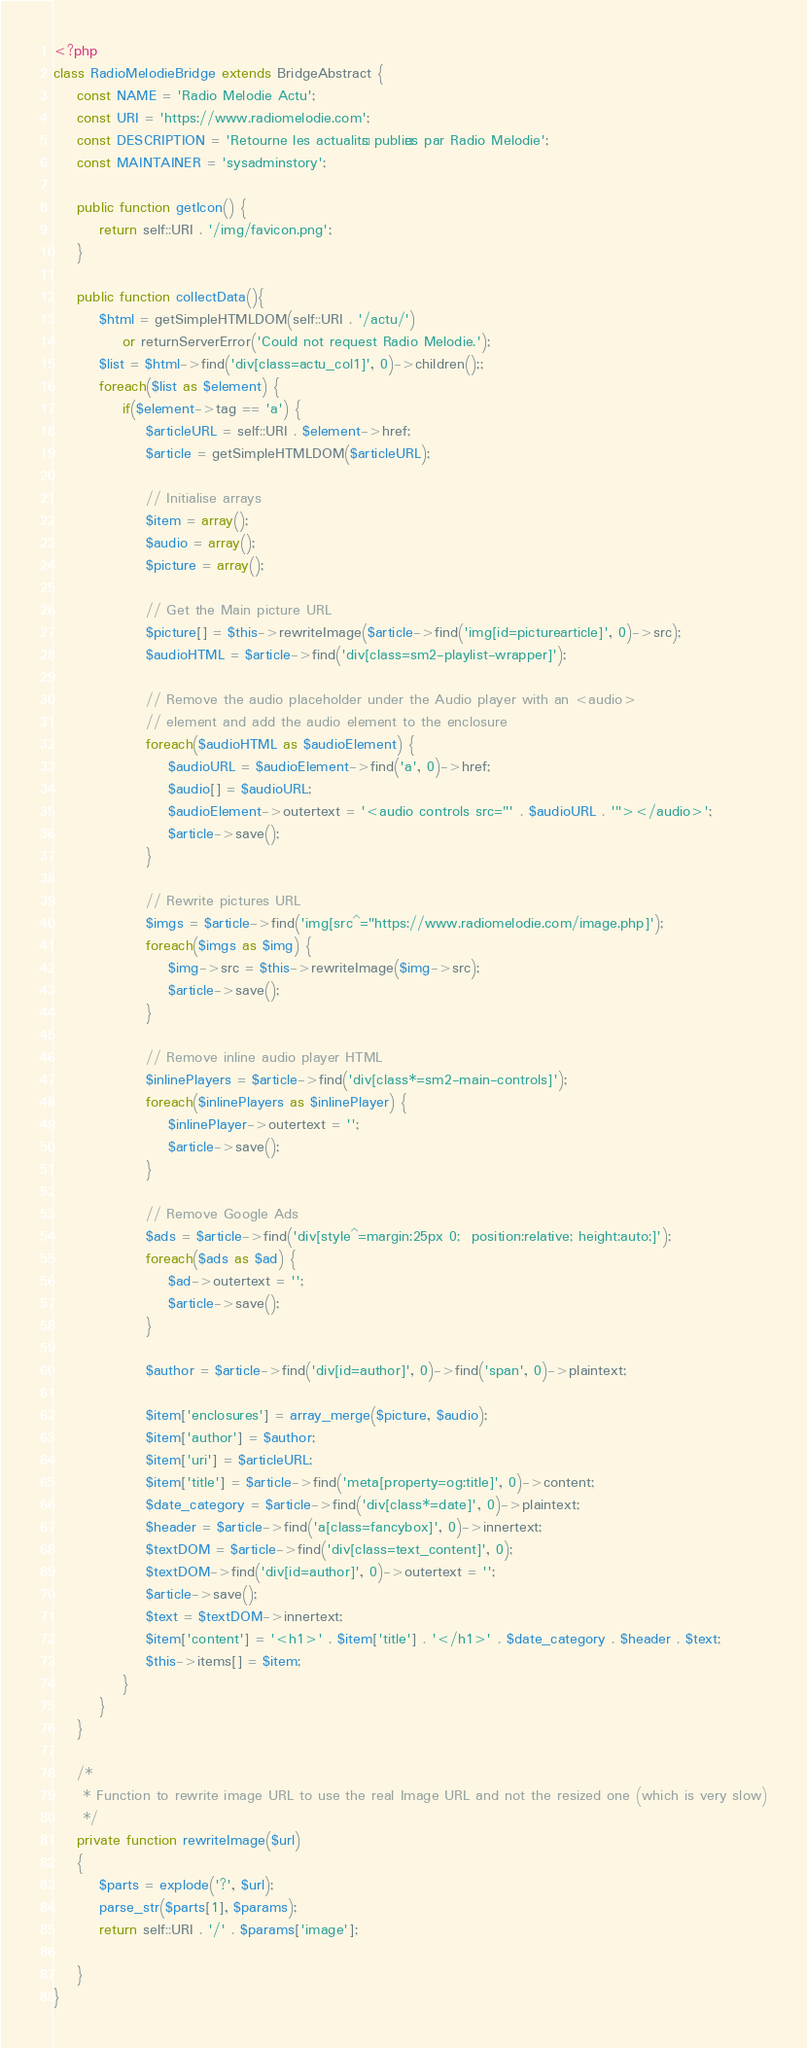<code> <loc_0><loc_0><loc_500><loc_500><_PHP_><?php
class RadioMelodieBridge extends BridgeAbstract {
	const NAME = 'Radio Melodie Actu';
	const URI = 'https://www.radiomelodie.com';
	const DESCRIPTION = 'Retourne les actualités publiées par Radio Melodie';
	const MAINTAINER = 'sysadminstory';

	public function getIcon() {
		return self::URI . '/img/favicon.png';
	}

	public function collectData(){
		$html = getSimpleHTMLDOM(self::URI . '/actu/')
			or returnServerError('Could not request Radio Melodie.');
		$list = $html->find('div[class=actu_col1]', 0)->children();;
		foreach($list as $element) {
			if($element->tag == 'a') {
				$articleURL = self::URI . $element->href;
				$article = getSimpleHTMLDOM($articleURL);

				// Initialise arrays
				$item = array();
				$audio = array();
				$picture = array();

				// Get the Main picture URL
				$picture[] = $this->rewriteImage($article->find('img[id=picturearticle]', 0)->src);
				$audioHTML = $article->find('div[class=sm2-playlist-wrapper]');

				// Remove the audio placeholder under the Audio player with an <audio>
				// element and add the audio element to the enclosure
				foreach($audioHTML as $audioElement) {
					$audioURL = $audioElement->find('a', 0)->href;
					$audio[] = $audioURL;
					$audioElement->outertext = '<audio controls src="' . $audioURL . '"></audio>';
					$article->save();
				}

				// Rewrite pictures URL
				$imgs = $article->find('img[src^="https://www.radiomelodie.com/image.php]');
				foreach($imgs as $img) {
					$img->src = $this->rewriteImage($img->src);
					$article->save();
				}

				// Remove inline audio player HTML
				$inlinePlayers = $article->find('div[class*=sm2-main-controls]');
				foreach($inlinePlayers as $inlinePlayer) {
					$inlinePlayer->outertext = '';
					$article->save();
				}

				// Remove Google Ads
				$ads = $article->find('div[style^=margin:25px 0;  position:relative; height:auto;]');
				foreach($ads as $ad) {
					$ad->outertext = '';
					$article->save();
				}

				$author = $article->find('div[id=author]', 0)->find('span', 0)->plaintext;

				$item['enclosures'] = array_merge($picture, $audio);
				$item['author'] = $author;
				$item['uri'] = $articleURL;
				$item['title'] = $article->find('meta[property=og:title]', 0)->content;
				$date_category = $article->find('div[class*=date]', 0)->plaintext;
				$header = $article->find('a[class=fancybox]', 0)->innertext;
				$textDOM = $article->find('div[class=text_content]', 0);
				$textDOM->find('div[id=author]', 0)->outertext = '';
				$article->save();
				$text = $textDOM->innertext;
				$item['content'] = '<h1>' . $item['title'] . '</h1>' . $date_category . $header . $text;
				$this->items[] = $item;
			}
		}
	}

	/*
	 * Function to rewrite image URL to use the real Image URL and not the resized one (which is very slow)
	 */
	private function rewriteImage($url)
	{
		$parts = explode('?', $url);
		parse_str($parts[1], $params);
		return self::URI . '/' . $params['image'];

	}
}
</code> 